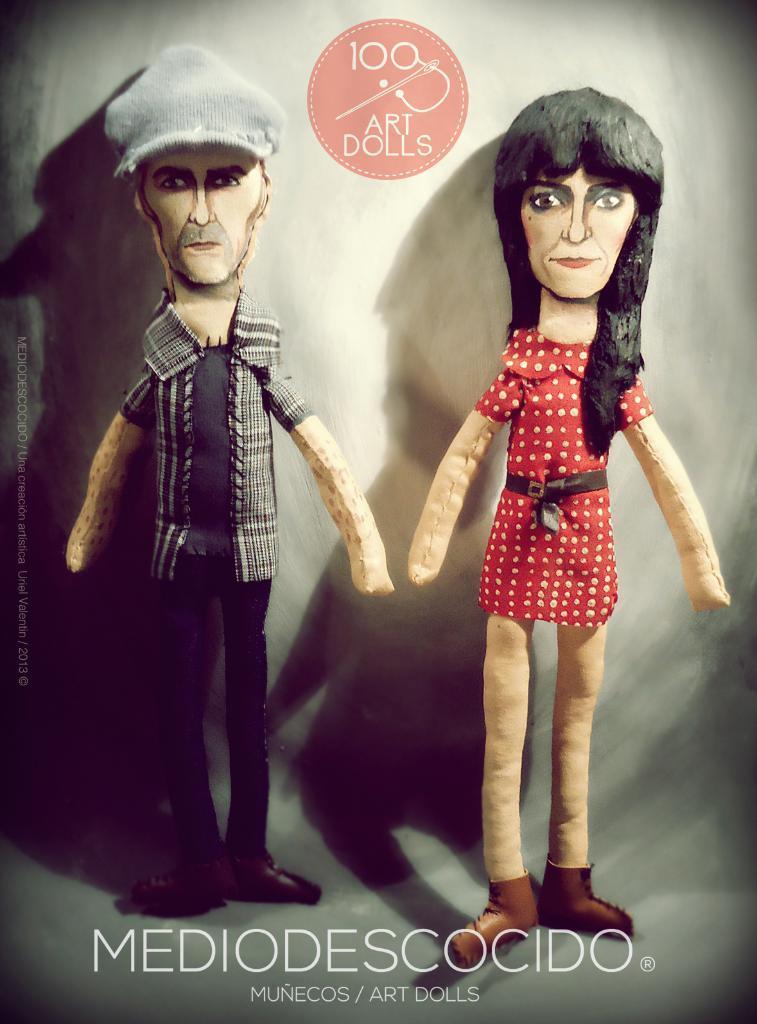How would you summarize this image in a sentence or two? This is an cartoon image of a man and a woman and we see text at the bottom of the picture and a logo with text on the top of the picture. 